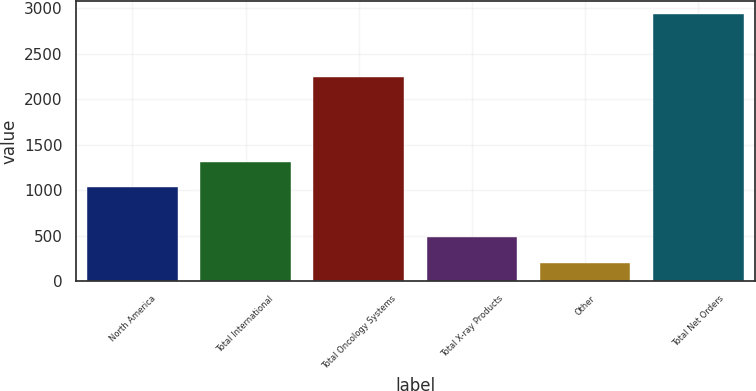<chart> <loc_0><loc_0><loc_500><loc_500><bar_chart><fcel>North America<fcel>Total International<fcel>Total Oncology Systems<fcel>Total X-ray Products<fcel>Other<fcel>Total Net Orders<nl><fcel>1038<fcel>1311.2<fcel>2249<fcel>483<fcel>201<fcel>2933<nl></chart> 